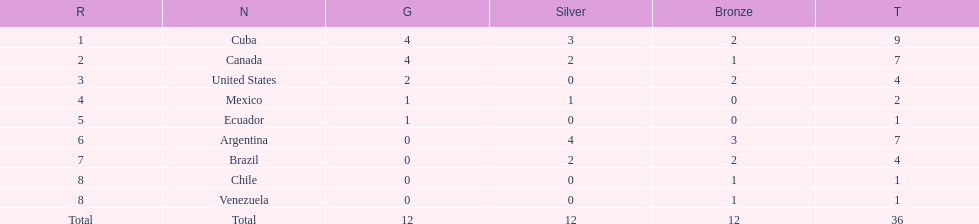Which nation obtained the largest accumulation of bronze medals? Argentina. 